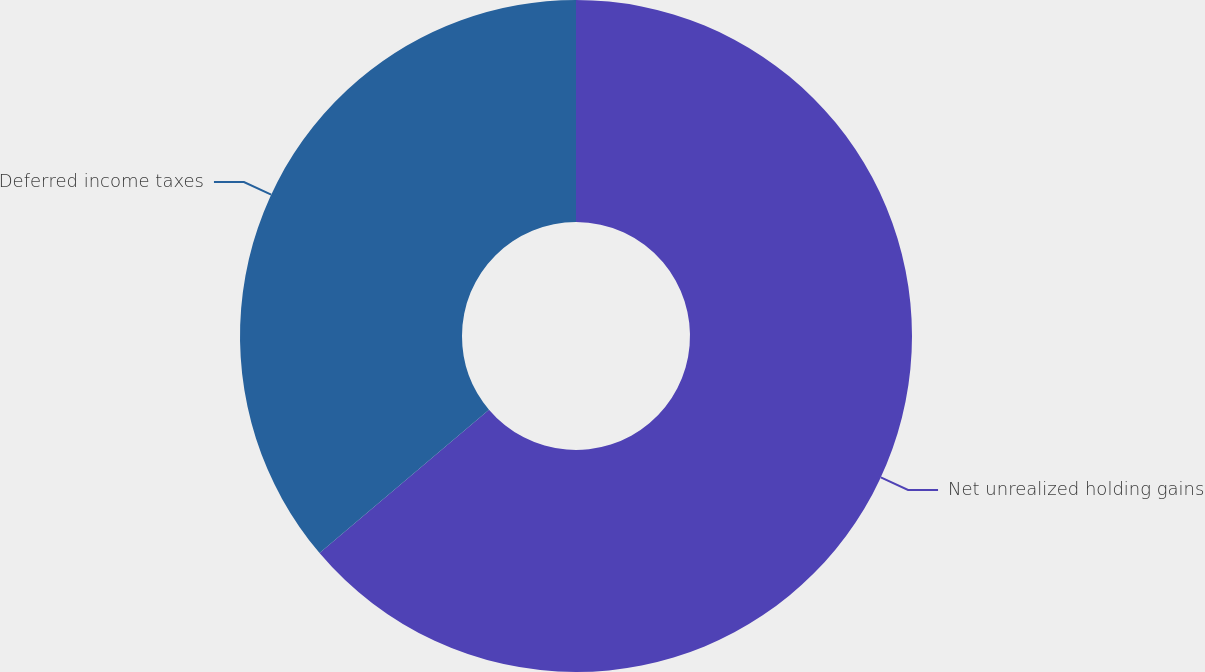<chart> <loc_0><loc_0><loc_500><loc_500><pie_chart><fcel>Net unrealized holding gains<fcel>Deferred income taxes<nl><fcel>63.82%<fcel>36.18%<nl></chart> 